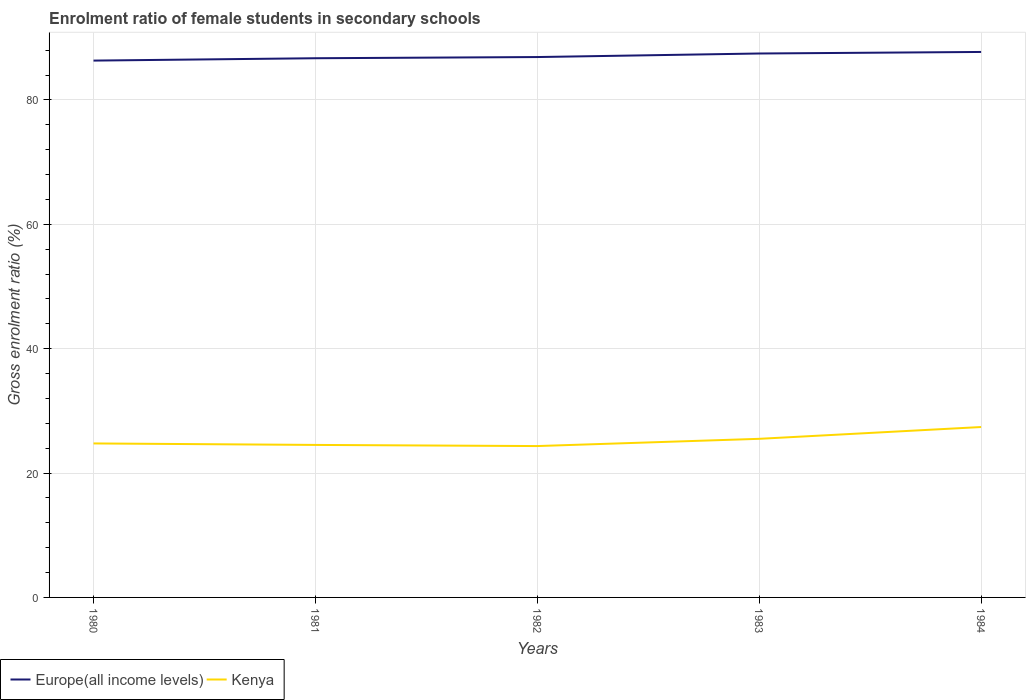Does the line corresponding to Kenya intersect with the line corresponding to Europe(all income levels)?
Your response must be concise. No. Is the number of lines equal to the number of legend labels?
Provide a succinct answer. Yes. Across all years, what is the maximum enrolment ratio of female students in secondary schools in Kenya?
Give a very brief answer. 24.34. What is the total enrolment ratio of female students in secondary schools in Europe(all income levels) in the graph?
Give a very brief answer. -1.39. What is the difference between the highest and the second highest enrolment ratio of female students in secondary schools in Europe(all income levels)?
Offer a terse response. 1.39. What is the difference between the highest and the lowest enrolment ratio of female students in secondary schools in Europe(all income levels)?
Offer a terse response. 2. How many lines are there?
Ensure brevity in your answer.  2. How many years are there in the graph?
Keep it short and to the point. 5. What is the difference between two consecutive major ticks on the Y-axis?
Give a very brief answer. 20. Does the graph contain grids?
Your answer should be compact. Yes. What is the title of the graph?
Ensure brevity in your answer.  Enrolment ratio of female students in secondary schools. What is the Gross enrolment ratio (%) in Europe(all income levels) in 1980?
Give a very brief answer. 86.33. What is the Gross enrolment ratio (%) of Kenya in 1980?
Your answer should be compact. 24.76. What is the Gross enrolment ratio (%) in Europe(all income levels) in 1981?
Your answer should be very brief. 86.71. What is the Gross enrolment ratio (%) in Kenya in 1981?
Your answer should be compact. 24.53. What is the Gross enrolment ratio (%) in Europe(all income levels) in 1982?
Ensure brevity in your answer.  86.9. What is the Gross enrolment ratio (%) in Kenya in 1982?
Keep it short and to the point. 24.34. What is the Gross enrolment ratio (%) in Europe(all income levels) in 1983?
Your response must be concise. 87.47. What is the Gross enrolment ratio (%) in Kenya in 1983?
Provide a short and direct response. 25.51. What is the Gross enrolment ratio (%) of Europe(all income levels) in 1984?
Ensure brevity in your answer.  87.72. What is the Gross enrolment ratio (%) of Kenya in 1984?
Your answer should be compact. 27.4. Across all years, what is the maximum Gross enrolment ratio (%) of Europe(all income levels)?
Your answer should be compact. 87.72. Across all years, what is the maximum Gross enrolment ratio (%) in Kenya?
Give a very brief answer. 27.4. Across all years, what is the minimum Gross enrolment ratio (%) of Europe(all income levels)?
Keep it short and to the point. 86.33. Across all years, what is the minimum Gross enrolment ratio (%) of Kenya?
Keep it short and to the point. 24.34. What is the total Gross enrolment ratio (%) in Europe(all income levels) in the graph?
Your response must be concise. 435.14. What is the total Gross enrolment ratio (%) of Kenya in the graph?
Offer a very short reply. 126.54. What is the difference between the Gross enrolment ratio (%) of Europe(all income levels) in 1980 and that in 1981?
Provide a short and direct response. -0.38. What is the difference between the Gross enrolment ratio (%) of Kenya in 1980 and that in 1981?
Give a very brief answer. 0.24. What is the difference between the Gross enrolment ratio (%) in Europe(all income levels) in 1980 and that in 1982?
Provide a succinct answer. -0.57. What is the difference between the Gross enrolment ratio (%) of Kenya in 1980 and that in 1982?
Provide a short and direct response. 0.42. What is the difference between the Gross enrolment ratio (%) of Europe(all income levels) in 1980 and that in 1983?
Make the answer very short. -1.14. What is the difference between the Gross enrolment ratio (%) in Kenya in 1980 and that in 1983?
Make the answer very short. -0.74. What is the difference between the Gross enrolment ratio (%) of Europe(all income levels) in 1980 and that in 1984?
Provide a succinct answer. -1.39. What is the difference between the Gross enrolment ratio (%) of Kenya in 1980 and that in 1984?
Your answer should be very brief. -2.64. What is the difference between the Gross enrolment ratio (%) of Europe(all income levels) in 1981 and that in 1982?
Your answer should be compact. -0.19. What is the difference between the Gross enrolment ratio (%) in Kenya in 1981 and that in 1982?
Give a very brief answer. 0.18. What is the difference between the Gross enrolment ratio (%) of Europe(all income levels) in 1981 and that in 1983?
Make the answer very short. -0.76. What is the difference between the Gross enrolment ratio (%) in Kenya in 1981 and that in 1983?
Your answer should be very brief. -0.98. What is the difference between the Gross enrolment ratio (%) in Europe(all income levels) in 1981 and that in 1984?
Ensure brevity in your answer.  -1.01. What is the difference between the Gross enrolment ratio (%) in Kenya in 1981 and that in 1984?
Keep it short and to the point. -2.88. What is the difference between the Gross enrolment ratio (%) of Europe(all income levels) in 1982 and that in 1983?
Your answer should be compact. -0.57. What is the difference between the Gross enrolment ratio (%) in Kenya in 1982 and that in 1983?
Your answer should be compact. -1.16. What is the difference between the Gross enrolment ratio (%) of Europe(all income levels) in 1982 and that in 1984?
Make the answer very short. -0.82. What is the difference between the Gross enrolment ratio (%) in Kenya in 1982 and that in 1984?
Offer a terse response. -3.06. What is the difference between the Gross enrolment ratio (%) in Europe(all income levels) in 1983 and that in 1984?
Give a very brief answer. -0.25. What is the difference between the Gross enrolment ratio (%) of Kenya in 1983 and that in 1984?
Your answer should be compact. -1.9. What is the difference between the Gross enrolment ratio (%) of Europe(all income levels) in 1980 and the Gross enrolment ratio (%) of Kenya in 1981?
Provide a succinct answer. 61.81. What is the difference between the Gross enrolment ratio (%) of Europe(all income levels) in 1980 and the Gross enrolment ratio (%) of Kenya in 1982?
Offer a terse response. 61.99. What is the difference between the Gross enrolment ratio (%) in Europe(all income levels) in 1980 and the Gross enrolment ratio (%) in Kenya in 1983?
Offer a terse response. 60.82. What is the difference between the Gross enrolment ratio (%) in Europe(all income levels) in 1980 and the Gross enrolment ratio (%) in Kenya in 1984?
Your answer should be very brief. 58.93. What is the difference between the Gross enrolment ratio (%) of Europe(all income levels) in 1981 and the Gross enrolment ratio (%) of Kenya in 1982?
Give a very brief answer. 62.37. What is the difference between the Gross enrolment ratio (%) in Europe(all income levels) in 1981 and the Gross enrolment ratio (%) in Kenya in 1983?
Make the answer very short. 61.21. What is the difference between the Gross enrolment ratio (%) of Europe(all income levels) in 1981 and the Gross enrolment ratio (%) of Kenya in 1984?
Offer a terse response. 59.31. What is the difference between the Gross enrolment ratio (%) of Europe(all income levels) in 1982 and the Gross enrolment ratio (%) of Kenya in 1983?
Provide a short and direct response. 61.39. What is the difference between the Gross enrolment ratio (%) in Europe(all income levels) in 1982 and the Gross enrolment ratio (%) in Kenya in 1984?
Ensure brevity in your answer.  59.5. What is the difference between the Gross enrolment ratio (%) of Europe(all income levels) in 1983 and the Gross enrolment ratio (%) of Kenya in 1984?
Your answer should be compact. 60.07. What is the average Gross enrolment ratio (%) in Europe(all income levels) per year?
Make the answer very short. 87.03. What is the average Gross enrolment ratio (%) in Kenya per year?
Keep it short and to the point. 25.31. In the year 1980, what is the difference between the Gross enrolment ratio (%) of Europe(all income levels) and Gross enrolment ratio (%) of Kenya?
Give a very brief answer. 61.57. In the year 1981, what is the difference between the Gross enrolment ratio (%) of Europe(all income levels) and Gross enrolment ratio (%) of Kenya?
Keep it short and to the point. 62.19. In the year 1982, what is the difference between the Gross enrolment ratio (%) of Europe(all income levels) and Gross enrolment ratio (%) of Kenya?
Offer a terse response. 62.56. In the year 1983, what is the difference between the Gross enrolment ratio (%) of Europe(all income levels) and Gross enrolment ratio (%) of Kenya?
Keep it short and to the point. 61.97. In the year 1984, what is the difference between the Gross enrolment ratio (%) of Europe(all income levels) and Gross enrolment ratio (%) of Kenya?
Offer a terse response. 60.32. What is the ratio of the Gross enrolment ratio (%) of Europe(all income levels) in 1980 to that in 1981?
Give a very brief answer. 1. What is the ratio of the Gross enrolment ratio (%) in Kenya in 1980 to that in 1981?
Your answer should be very brief. 1.01. What is the ratio of the Gross enrolment ratio (%) in Kenya in 1980 to that in 1982?
Offer a terse response. 1.02. What is the ratio of the Gross enrolment ratio (%) of Europe(all income levels) in 1980 to that in 1983?
Offer a very short reply. 0.99. What is the ratio of the Gross enrolment ratio (%) of Kenya in 1980 to that in 1983?
Offer a terse response. 0.97. What is the ratio of the Gross enrolment ratio (%) in Europe(all income levels) in 1980 to that in 1984?
Give a very brief answer. 0.98. What is the ratio of the Gross enrolment ratio (%) in Kenya in 1980 to that in 1984?
Your response must be concise. 0.9. What is the ratio of the Gross enrolment ratio (%) of Europe(all income levels) in 1981 to that in 1982?
Your response must be concise. 1. What is the ratio of the Gross enrolment ratio (%) of Kenya in 1981 to that in 1982?
Your answer should be very brief. 1.01. What is the ratio of the Gross enrolment ratio (%) of Kenya in 1981 to that in 1983?
Your answer should be very brief. 0.96. What is the ratio of the Gross enrolment ratio (%) in Europe(all income levels) in 1981 to that in 1984?
Keep it short and to the point. 0.99. What is the ratio of the Gross enrolment ratio (%) in Kenya in 1981 to that in 1984?
Your answer should be very brief. 0.9. What is the ratio of the Gross enrolment ratio (%) in Europe(all income levels) in 1982 to that in 1983?
Your answer should be very brief. 0.99. What is the ratio of the Gross enrolment ratio (%) in Kenya in 1982 to that in 1983?
Your response must be concise. 0.95. What is the ratio of the Gross enrolment ratio (%) of Kenya in 1982 to that in 1984?
Your answer should be compact. 0.89. What is the ratio of the Gross enrolment ratio (%) in Kenya in 1983 to that in 1984?
Offer a terse response. 0.93. What is the difference between the highest and the second highest Gross enrolment ratio (%) in Europe(all income levels)?
Keep it short and to the point. 0.25. What is the difference between the highest and the second highest Gross enrolment ratio (%) of Kenya?
Ensure brevity in your answer.  1.9. What is the difference between the highest and the lowest Gross enrolment ratio (%) of Europe(all income levels)?
Keep it short and to the point. 1.39. What is the difference between the highest and the lowest Gross enrolment ratio (%) in Kenya?
Give a very brief answer. 3.06. 